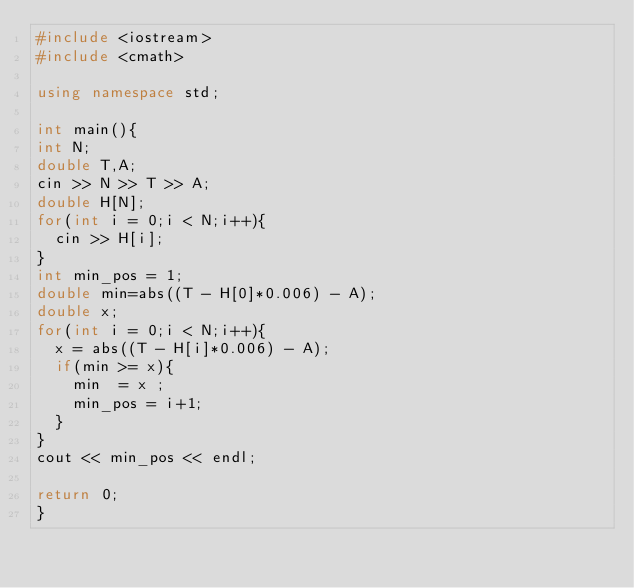Convert code to text. <code><loc_0><loc_0><loc_500><loc_500><_C++_>#include <iostream>
#include <cmath>

using namespace std;

int main(){
int N;
double T,A;
cin >> N >> T >> A;
double H[N];
for(int i = 0;i < N;i++){
  cin >> H[i];
}
int min_pos = 1;
double min=abs((T - H[0]*0.006) - A);
double x;
for(int i = 0;i < N;i++){
  x = abs((T - H[i]*0.006) - A);
  if(min >= x){
    min  = x ;
    min_pos = i+1;
  }
}
cout << min_pos << endl;

return 0;
}
</code> 